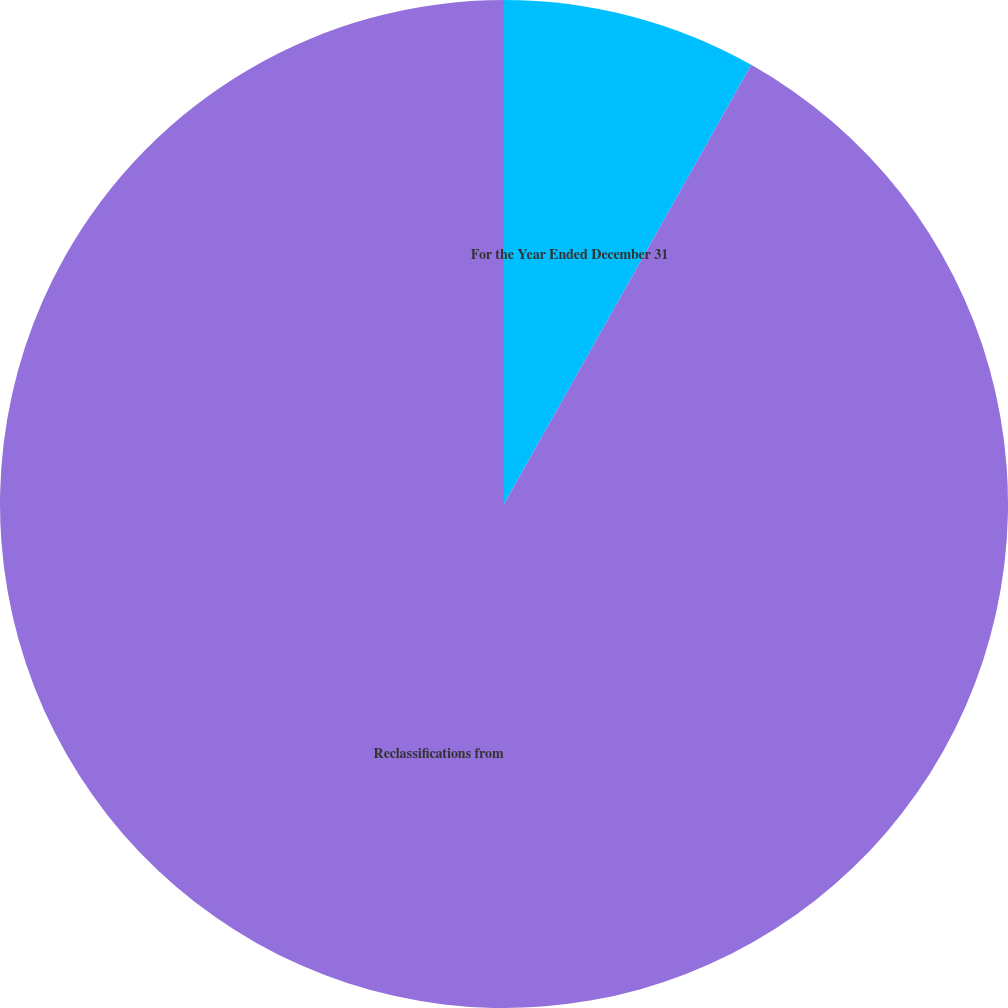Convert chart. <chart><loc_0><loc_0><loc_500><loc_500><pie_chart><fcel>For the Year Ended December 31<fcel>Reclassifications from<nl><fcel>8.16%<fcel>91.84%<nl></chart> 